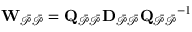Convert formula to latex. <formula><loc_0><loc_0><loc_500><loc_500>W _ { \mathcal { \ B a r { P } \ B a r { P } } } = Q _ { \mathcal { \ B a r { P } \ B a r { P } } } D _ { \mathcal { \ B a r { P } \ B a r { P } } } Q _ { \mathcal { \ B a r { P } \ B a r { P } } } ^ { - 1 }</formula> 